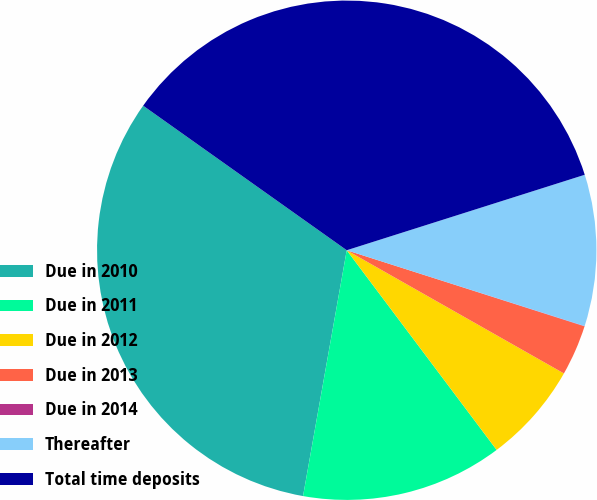Convert chart to OTSL. <chart><loc_0><loc_0><loc_500><loc_500><pie_chart><fcel>Due in 2010<fcel>Due in 2011<fcel>Due in 2012<fcel>Due in 2013<fcel>Due in 2014<fcel>Thereafter<fcel>Total time deposits<nl><fcel>32.03%<fcel>13.05%<fcel>6.54%<fcel>3.28%<fcel>0.02%<fcel>9.8%<fcel>35.29%<nl></chart> 